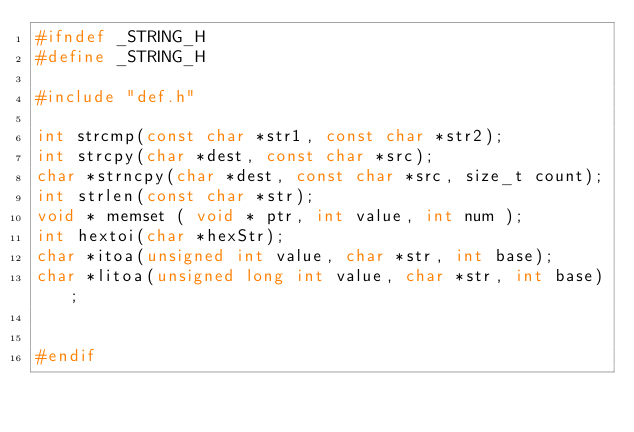Convert code to text. <code><loc_0><loc_0><loc_500><loc_500><_C_>#ifndef _STRING_H
#define _STRING_H

#include "def.h"

int strcmp(const char *str1, const char *str2);
int strcpy(char *dest, const char *src);
char *strncpy(char *dest, const char *src, size_t count);
int strlen(const char *str);
void * memset ( void * ptr, int value, int num );
int hextoi(char *hexStr);
char *itoa(unsigned int value, char *str, int base);
char *litoa(unsigned long int value, char *str, int base);


#endif</code> 